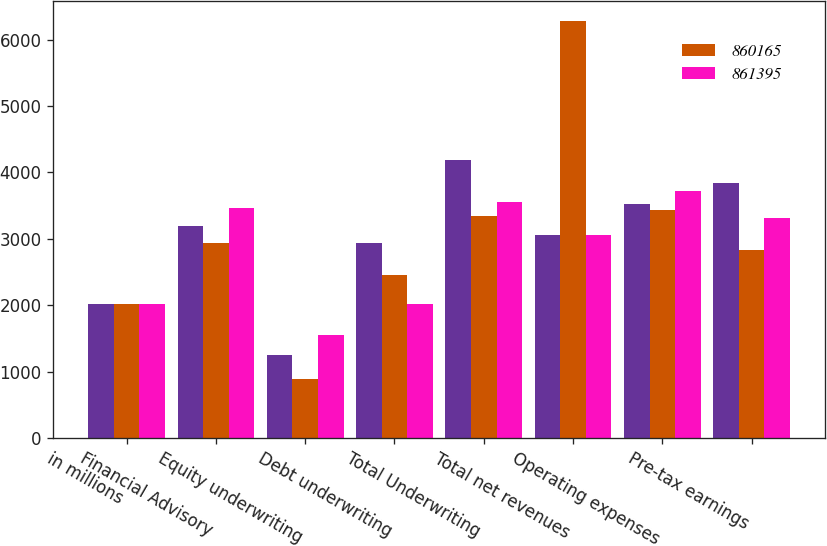Convert chart. <chart><loc_0><loc_0><loc_500><loc_500><stacked_bar_chart><ecel><fcel>in millions<fcel>Financial Advisory<fcel>Equity underwriting<fcel>Debt underwriting<fcel>Total Underwriting<fcel>Total net revenues<fcel>Operating expenses<fcel>Pre-tax earnings<nl><fcel>nan<fcel>2017<fcel>3188<fcel>1243<fcel>2940<fcel>4183<fcel>3064<fcel>3526<fcel>3845<nl><fcel>860165<fcel>2016<fcel>2932<fcel>891<fcel>2450<fcel>3341<fcel>6273<fcel>3437<fcel>2836<nl><fcel>861395<fcel>2015<fcel>3470<fcel>1546<fcel>2011<fcel>3557<fcel>3064<fcel>3713<fcel>3314<nl></chart> 